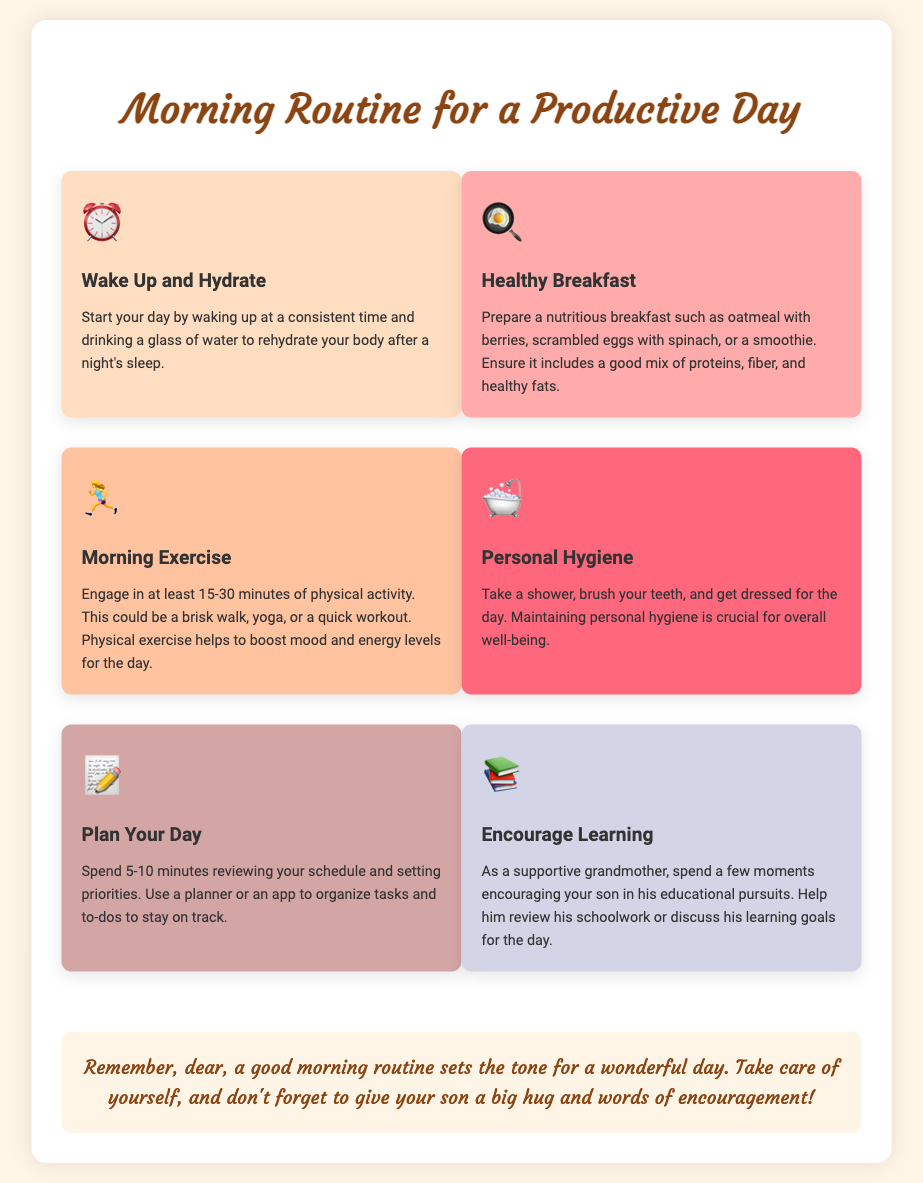What is the first step in the morning routine? The first step mentioned in the document is "Wake Up and Hydrate."
Answer: Wake Up and Hydrate How long should morning exercise last? The document specifies engaging in physical activity for at least 15-30 minutes.
Answer: 15-30 minutes What type of breakfast is recommended? The document suggests preparing a nutritious breakfast like oatmeal with berries or scrambled eggs with spinach.
Answer: Nutritious breakfast What should you do to maintain personal hygiene? The document mentions taking a shower, brushing teeth, and getting dressed.
Answer: Shower, brush teeth, get dressed What is the purpose of planning your day? The document states that planning helps in reviewing your schedule and setting priorities.
Answer: Reviewing schedule and setting priorities How many minutes should you spend encouraging learning? The document implies spending a few moments, specifically around a few minutes, encouraging educational pursuits.
Answer: A few moments What is the color of the step for Healthy Breakfast? The document indicates that the background color for Healthy Breakfast is light red.
Answer: Light red What icon represents the Morning Exercise step? The document features a running woman icon to represent the Morning Exercise step.
Answer: Running woman icon What note does the supportive grandmother give in the end? The grandmother notes that a good morning routine sets the tone for a wonderful day and emphasizes self-care.
Answer: A good morning routine sets the tone for a wonderful day 